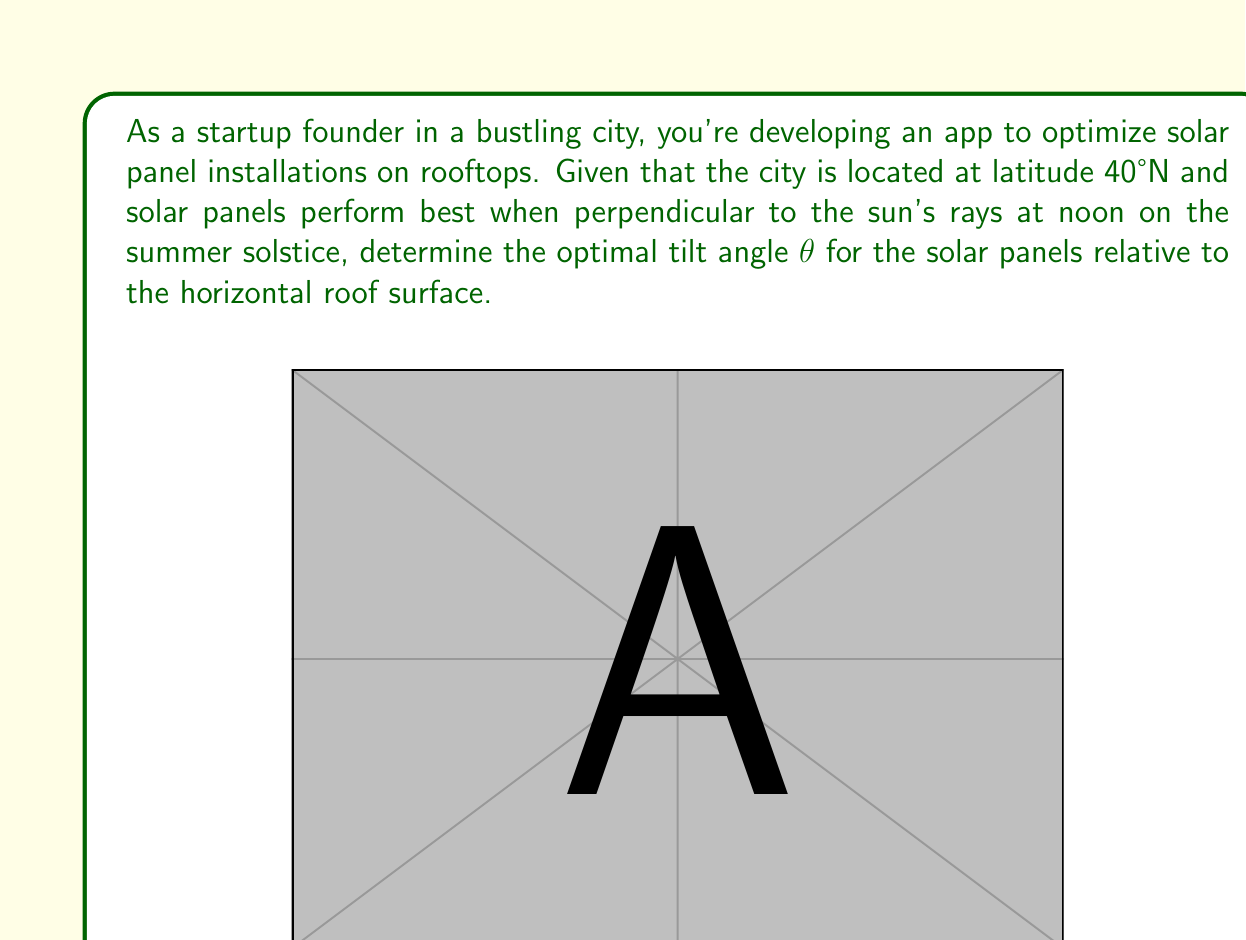Teach me how to tackle this problem. Let's approach this step-by-step:

1) On the summer solstice, the sun's declination (δ) is approximately 23.45°.

2) The solar elevation angle (α) at solar noon is given by:
   $$α = 90° - latitude + δ$$

3) Substituting the values:
   $$α = 90° - 40° + 23.45° = 73.45°$$

4) The optimal tilt angle (θ) for the solar panels should be perpendicular to the sun's rays. This means:
   $$θ + α = 90°$$

5) Solving for θ:
   $$θ = 90° - α = 90° - 73.45° = 16.55°$$

6) Rounding to the nearest degree:
   $$θ ≈ 17°$$

Therefore, the optimal tilt angle for the solar panels on city rooftops at 40°N latitude is approximately 17° from the horizontal.
Answer: $17°$ 